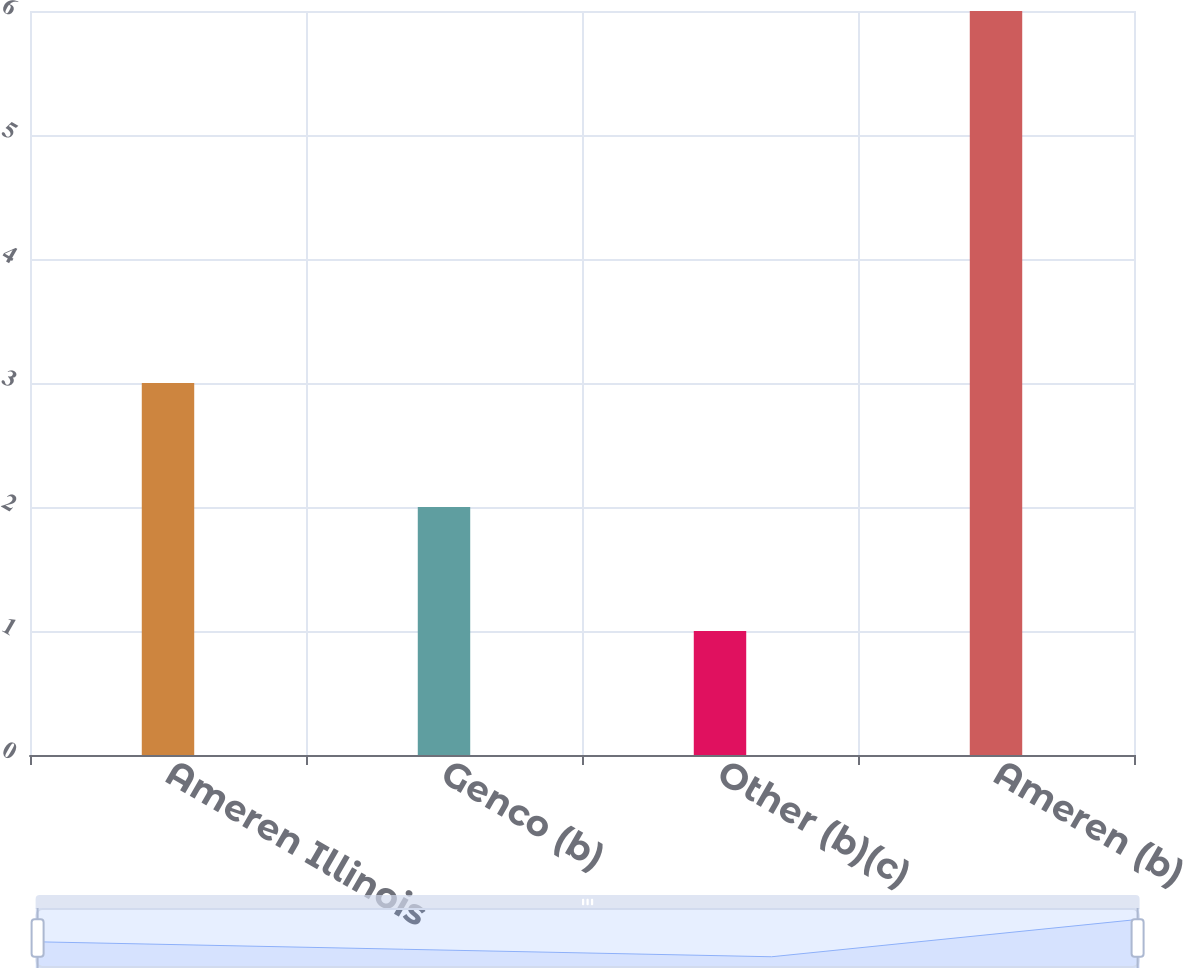Convert chart. <chart><loc_0><loc_0><loc_500><loc_500><bar_chart><fcel>Ameren Illinois<fcel>Genco (b)<fcel>Other (b)(c)<fcel>Ameren (b)<nl><fcel>3<fcel>2<fcel>1<fcel>6<nl></chart> 